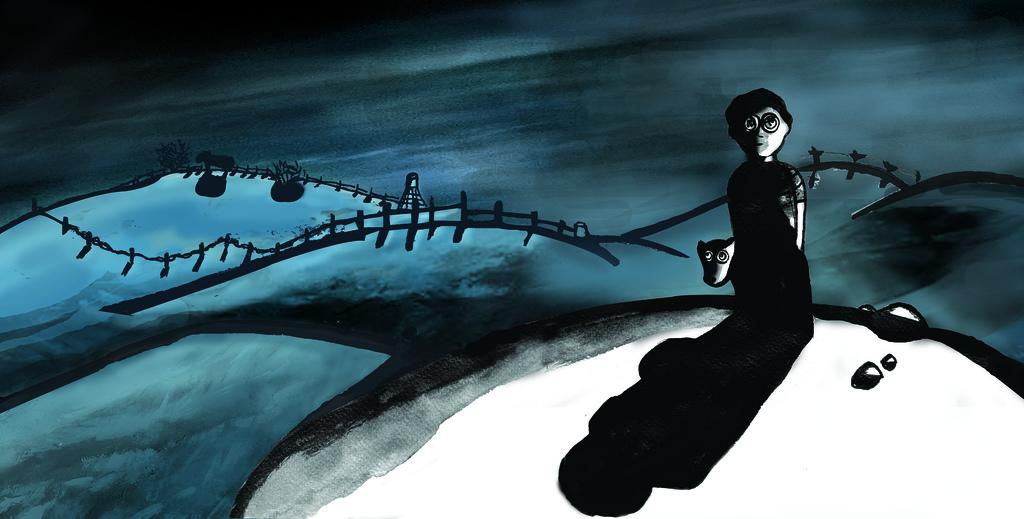Who or what can be seen in the image? There is a person and animals in the image. What else is present in the image besides the person and animals? There are plants, a fence, water, and other objects in the image. Can you describe the setting of the image? The image features a person and animals in a setting with plants, a fence, and water. What type of agreement is being discussed by the person and the maid in the image? There is no maid present in the image, and therefore no discussion about an agreement can be observed. 